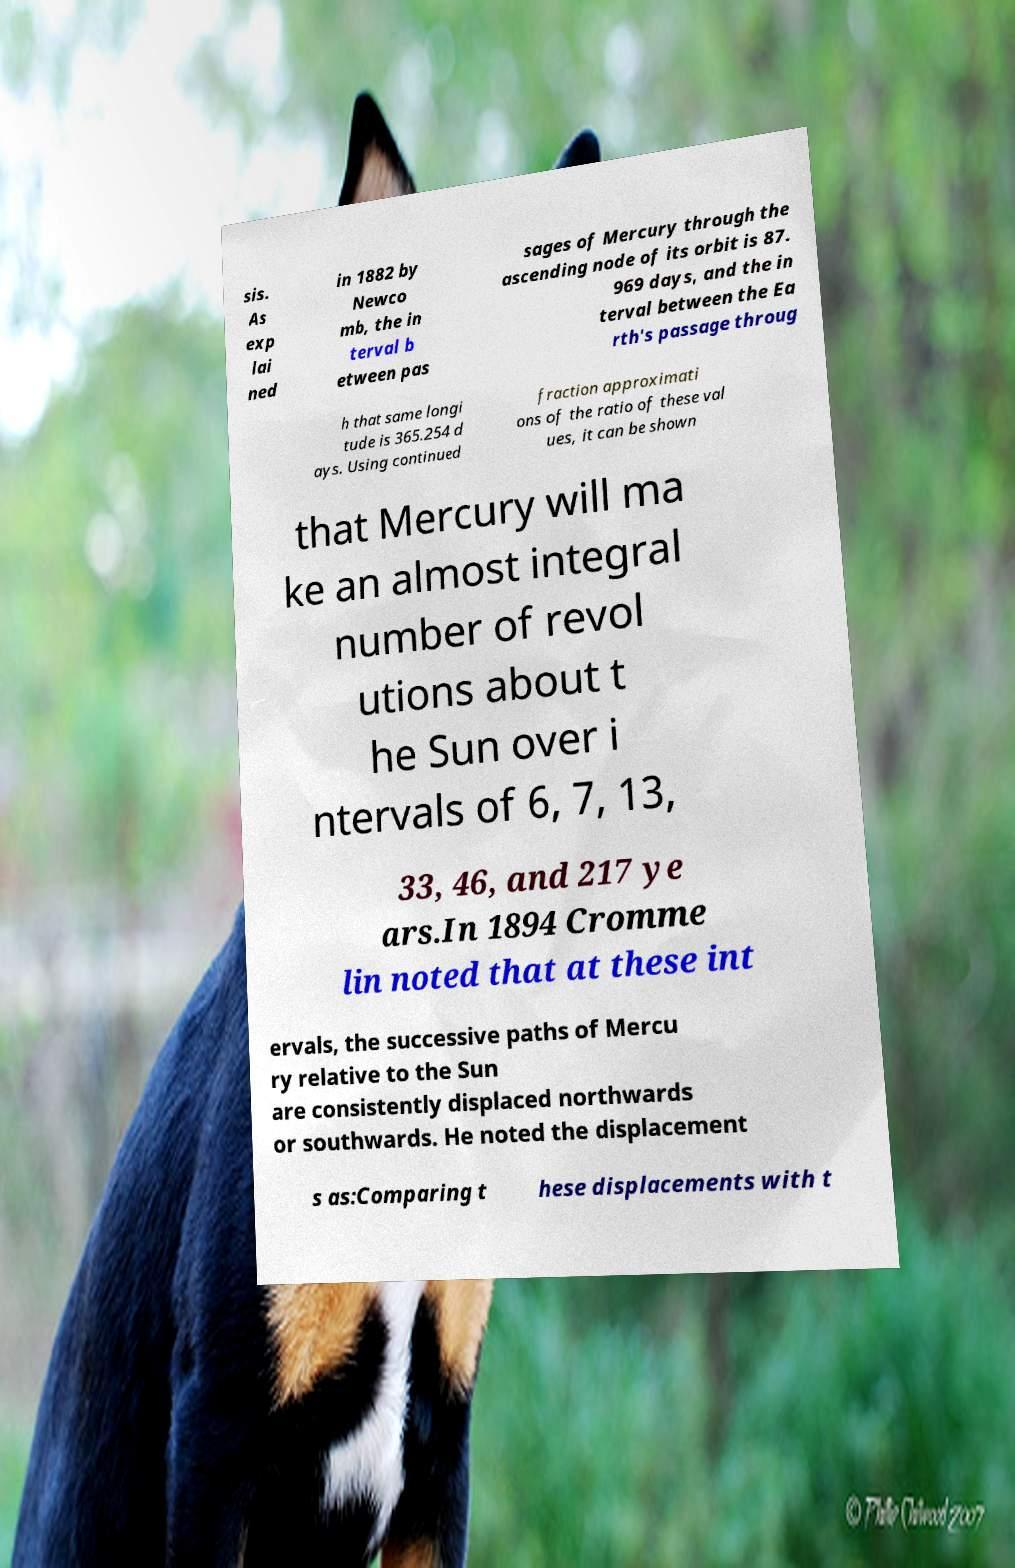What messages or text are displayed in this image? I need them in a readable, typed format. sis. As exp lai ned in 1882 by Newco mb, the in terval b etween pas sages of Mercury through the ascending node of its orbit is 87. 969 days, and the in terval between the Ea rth's passage throug h that same longi tude is 365.254 d ays. Using continued fraction approximati ons of the ratio of these val ues, it can be shown that Mercury will ma ke an almost integral number of revol utions about t he Sun over i ntervals of 6, 7, 13, 33, 46, and 217 ye ars.In 1894 Cromme lin noted that at these int ervals, the successive paths of Mercu ry relative to the Sun are consistently displaced northwards or southwards. He noted the displacement s as:Comparing t hese displacements with t 